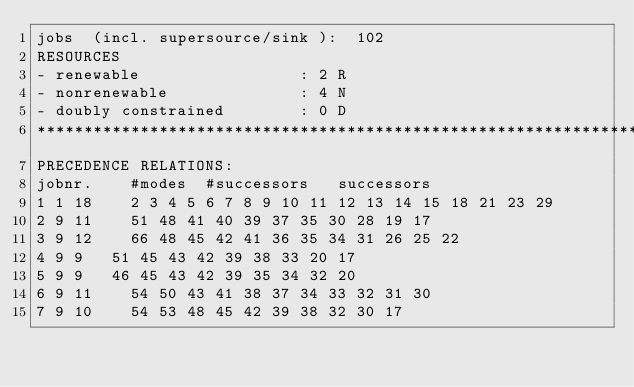Convert code to text. <code><loc_0><loc_0><loc_500><loc_500><_ObjectiveC_>jobs  (incl. supersource/sink ):	102
RESOURCES
- renewable                 : 2 R
- nonrenewable              : 4 N
- doubly constrained        : 0 D
************************************************************************
PRECEDENCE RELATIONS:
jobnr.    #modes  #successors   successors
1	1	18		2 3 4 5 6 7 8 9 10 11 12 13 14 15 18 21 23 29 
2	9	11		51 48 41 40 39 37 35 30 28 19 17 
3	9	12		66 48 45 42 41 36 35 34 31 26 25 22 
4	9	9		51 45 43 42 39 38 33 20 17 
5	9	9		46 45 43 42 39 35 34 32 20 
6	9	11		54 50 43 41 38 37 34 33 32 31 30 
7	9	10		54 53 48 45 42 39 38 32 30 17 </code> 